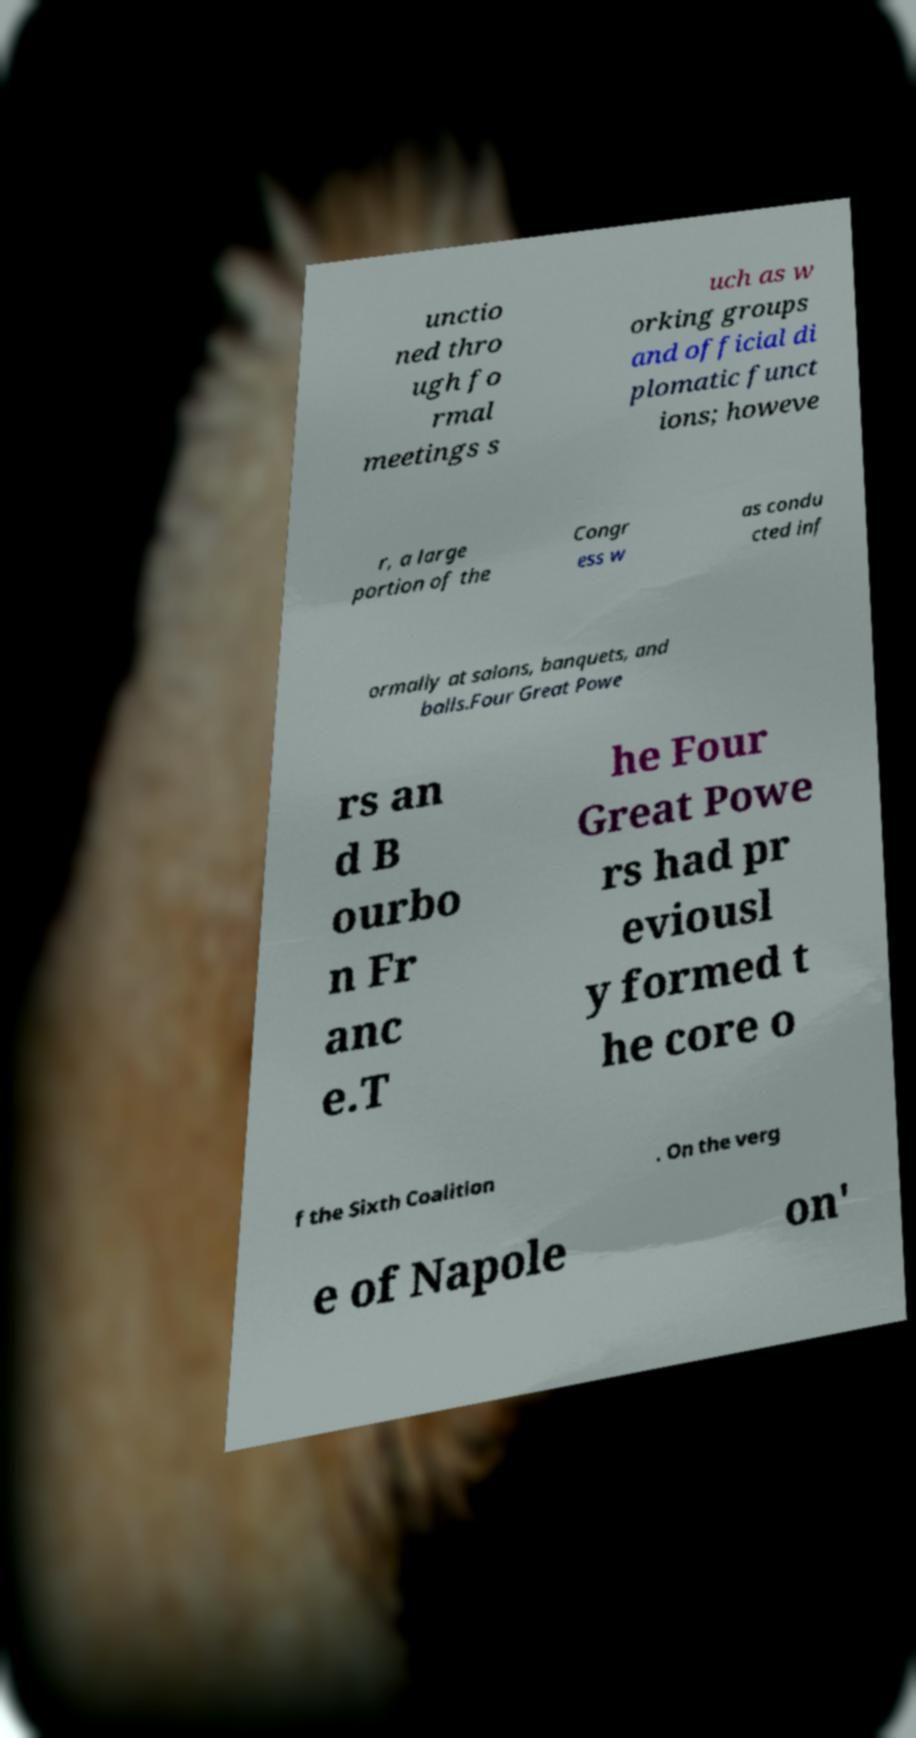Could you assist in decoding the text presented in this image and type it out clearly? unctio ned thro ugh fo rmal meetings s uch as w orking groups and official di plomatic funct ions; howeve r, a large portion of the Congr ess w as condu cted inf ormally at salons, banquets, and balls.Four Great Powe rs an d B ourbo n Fr anc e.T he Four Great Powe rs had pr eviousl y formed t he core o f the Sixth Coalition . On the verg e of Napole on' 